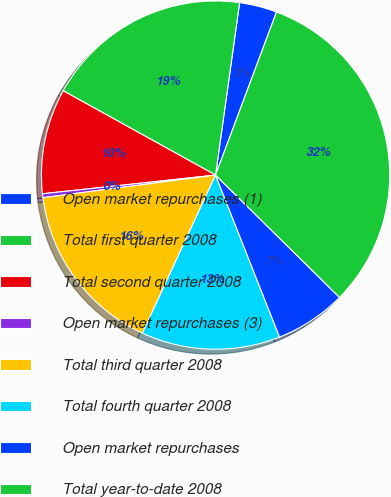Convert chart to OTSL. <chart><loc_0><loc_0><loc_500><loc_500><pie_chart><fcel>Open market repurchases (1)<fcel>Total first quarter 2008<fcel>Total second quarter 2008<fcel>Open market repurchases (3)<fcel>Total third quarter 2008<fcel>Total fourth quarter 2008<fcel>Open market repurchases<fcel>Total year-to-date 2008<nl><fcel>3.49%<fcel>19.16%<fcel>9.76%<fcel>0.36%<fcel>16.03%<fcel>12.89%<fcel>6.62%<fcel>31.7%<nl></chart> 